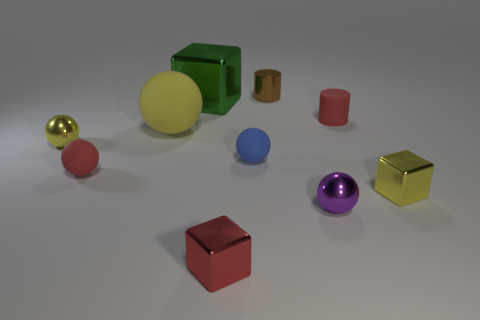Describe the lighting condition in the image. Does it appear as natural or artificial light? The lighting in the image looks artificial, with a soft overhead source creating subtle shadows beneath the objects, indicating it's likely rendered inside a 3D software. 